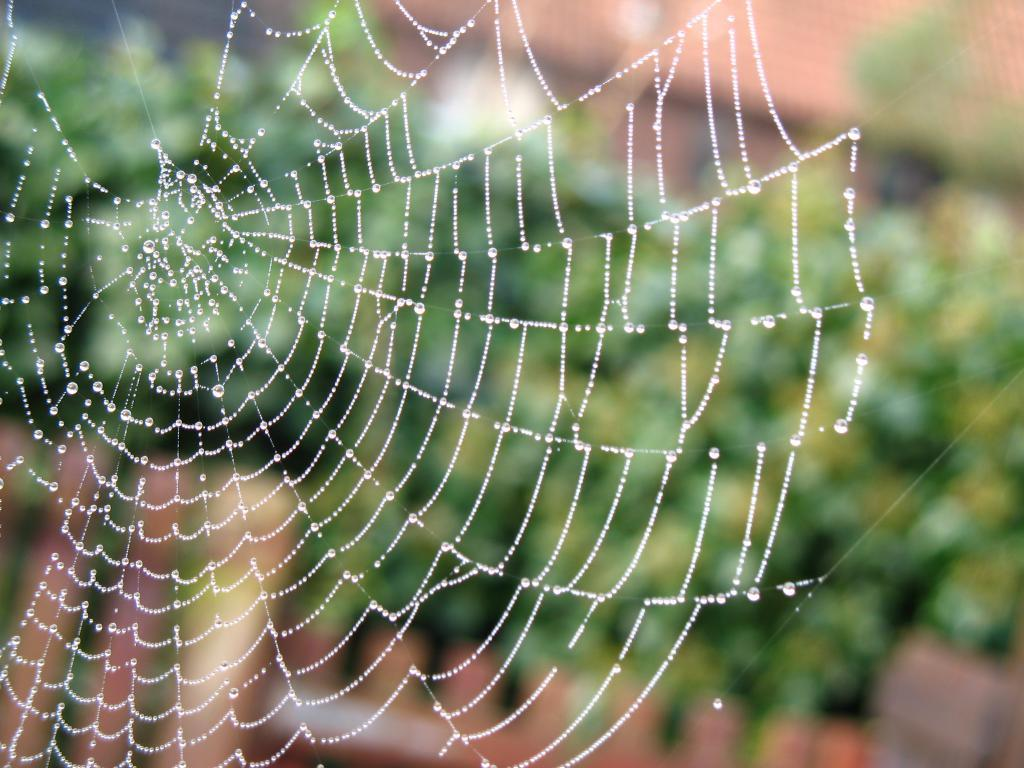What is present in the image? There is a spider web in the image. Can you describe the spider web? The spider web appears to be intricate and delicate. Is there any sign of a spider in the web? The image does not show a spider in the web. Where is the credit card located in the image? There is no credit card present in the image; it only features a spider web. What type of wheel can be seen in the image? There is no wheel present in the image; it only features a spider web. 